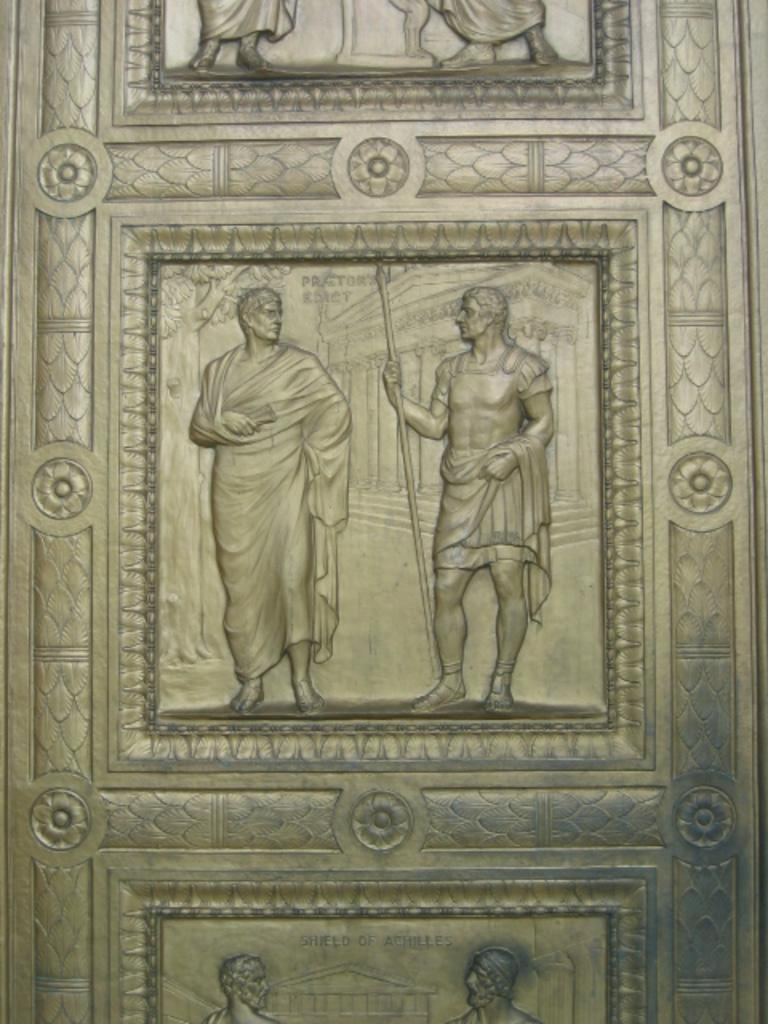What is present on the door in the image? There are sculptures on the door in the image. What type of leather is used to make the boat in the image? There is no boat present in the image; it only features sculptures on the door. 